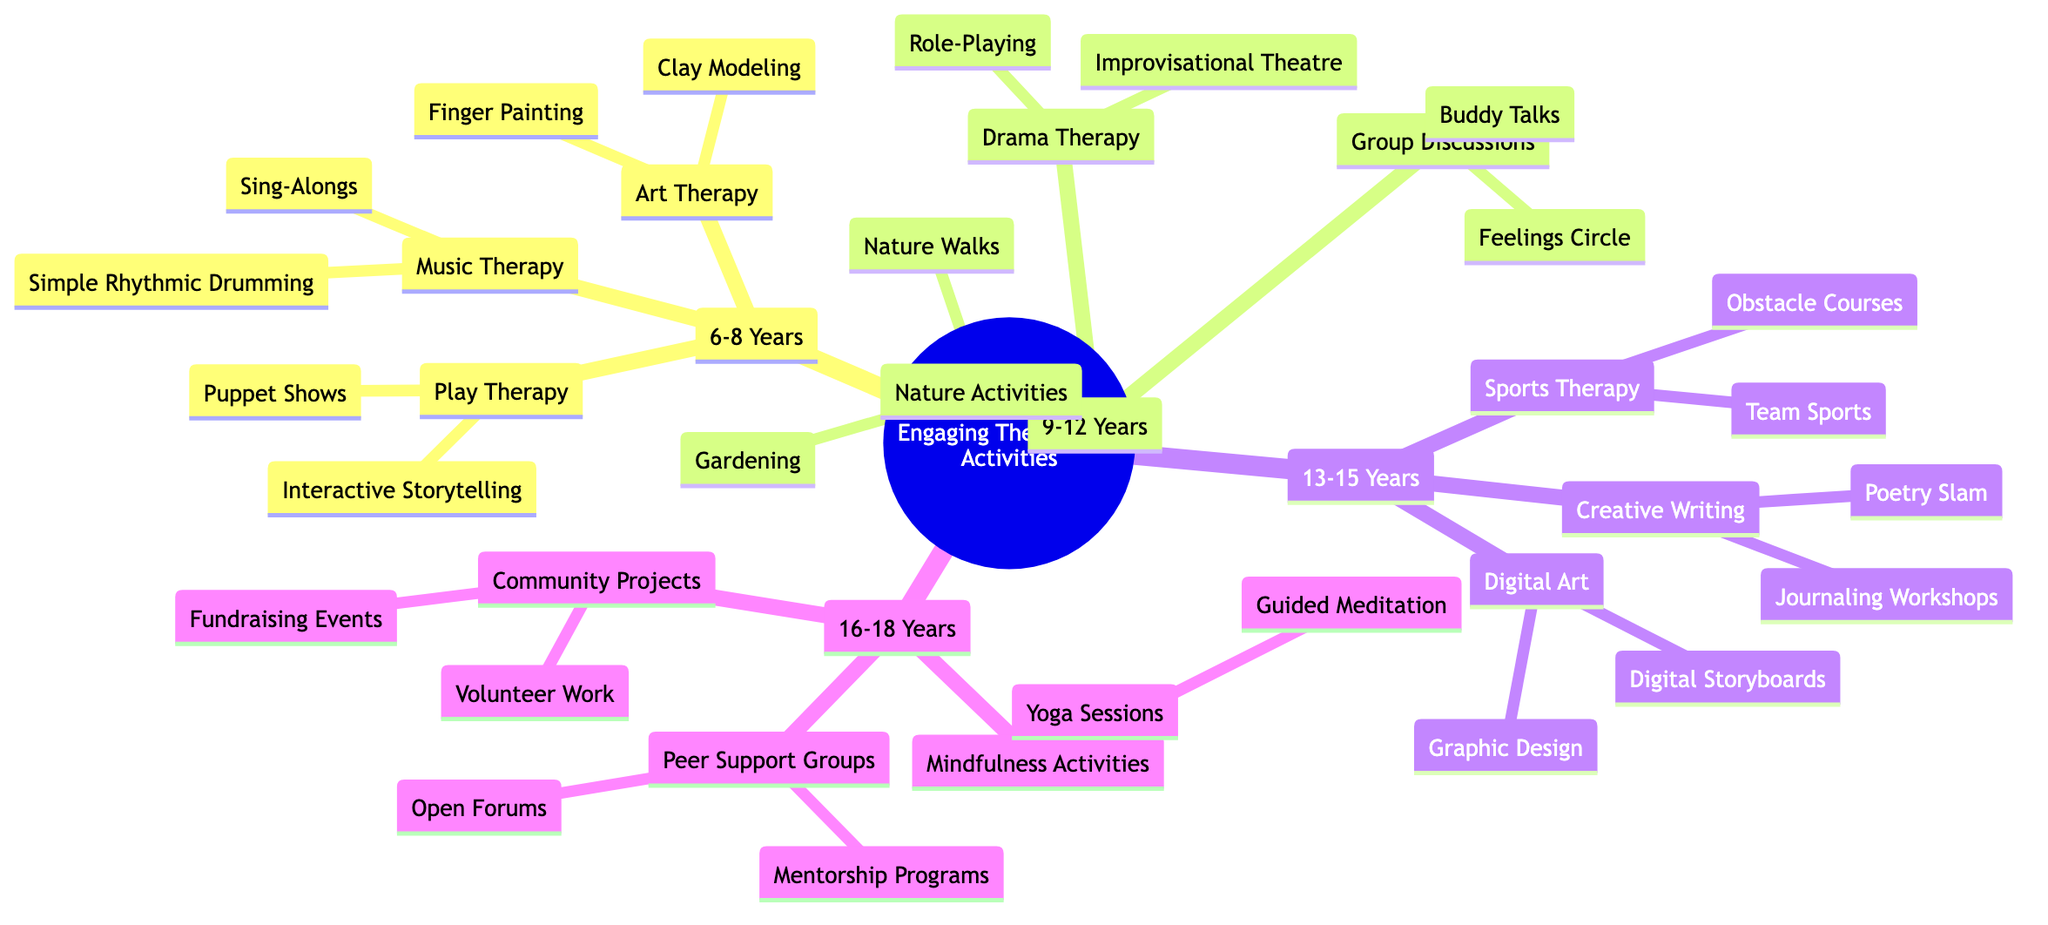What therapeutic activity is listed for 6-8 years under Art Therapy? The diagram shows two activities under the Art Therapy category for 6-8 years: Finger Painting and Clay Modeling. Since the question asks for one activity specifically, we can take either as a valid answer.
Answer: Finger Painting How many age groups are included in the diagram? The diagram specifies four age groups: 6-8 Years, 9-12 Years, 13-15 Years, and 16-18 Years. By counting the nodes under "Age Groups," we confirm the total number of distinct age categories.
Answer: 4 What is one of the activities mentioned for the 9-12 years under Nature Activities? The Nature Activities section for the 9-12 years includes Gardening and Nature Walks. As the question seeks one activity, we can provide either.
Answer: Gardening Which age group features Digital Art as a therapeutic activity? When examining the diagram, Digital Art appears only under the 13-15 years age group, which indicates that this activity is tailored for this specific group of participants.
Answer: 13-15 Years What type of therapy includes 'Guided Meditation'? The Mindfulness Activities section under the 16-18 years age group includes Guided Meditation. To determine this, we check the specific activities listed under Mindfulness Activities for that age category.
Answer: Mindfulness Activities What activity involves puppetry for the age group 6-8 years? Under the Play Therapy category for the 6-8 years age group, Puppet Shows is specifically identified, thus answering the inquiry regarding the activity that involves puppetry for children in that age bracket.
Answer: Puppet Shows Which activity uses a team-based approach in the 13-15 age group? The Sports Therapy category for the 13-15 years age group includes Team Sports, which explicitly states the involvement of teamwork as part of the therapeutic activities listed.
Answer: Team Sports How many activities are listed under the 16-18 years group for Community Projects? The 16-18 years group under Community Projects lists two activities: Volunteer Work and Fundraising Events. Therefore, by counting those activities, we arrive at the total number.
Answer: 2 What is the common element between Puppet Shows and Interactive Storytelling? Both Puppet Shows and Interactive Storytelling are listed under the Play Therapy category for the 6-8 years age group, demonstrating a common theme of imaginative play in early childhood therapeutic activities.
Answer: Play Therapy 